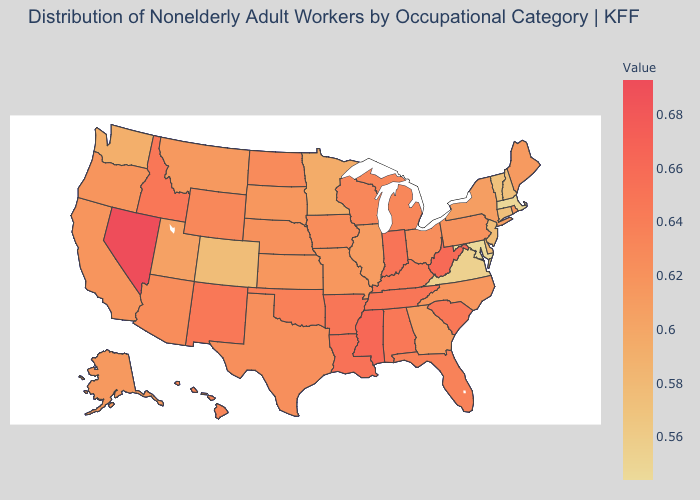Does the map have missing data?
Short answer required. No. Is the legend a continuous bar?
Quick response, please. Yes. Among the states that border South Carolina , which have the lowest value?
Write a very short answer. Georgia. Does Maryland have the lowest value in the USA?
Be succinct. Yes. Among the states that border Maryland , does Delaware have the highest value?
Give a very brief answer. No. Among the states that border Mississippi , does Alabama have the lowest value?
Keep it brief. Yes. 